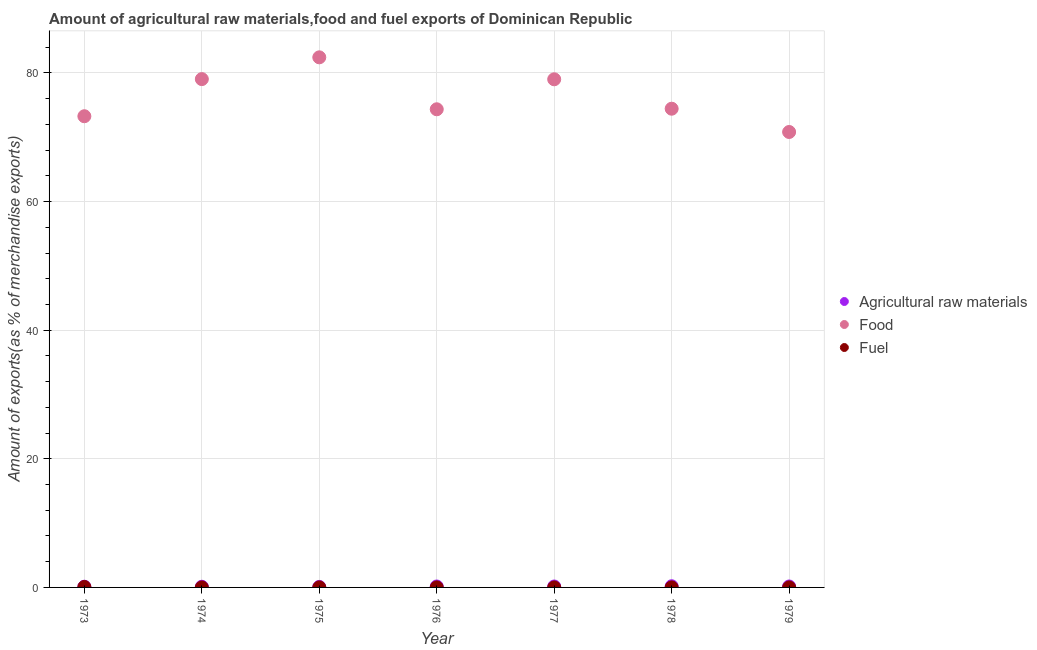What is the percentage of food exports in 1977?
Your answer should be very brief. 79.01. Across all years, what is the maximum percentage of raw materials exports?
Provide a short and direct response. 0.18. Across all years, what is the minimum percentage of fuel exports?
Give a very brief answer. 0. In which year was the percentage of raw materials exports maximum?
Make the answer very short. 1978. What is the total percentage of raw materials exports in the graph?
Offer a terse response. 0.91. What is the difference between the percentage of fuel exports in 1975 and that in 1976?
Your answer should be very brief. 0. What is the difference between the percentage of food exports in 1979 and the percentage of raw materials exports in 1974?
Your response must be concise. 70.71. What is the average percentage of raw materials exports per year?
Offer a very short reply. 0.13. In the year 1979, what is the difference between the percentage of food exports and percentage of raw materials exports?
Your answer should be compact. 70.67. In how many years, is the percentage of fuel exports greater than 24 %?
Your answer should be very brief. 0. What is the ratio of the percentage of fuel exports in 1975 to that in 1976?
Ensure brevity in your answer.  1.2. Is the percentage of food exports in 1978 less than that in 1979?
Provide a succinct answer. No. Is the difference between the percentage of raw materials exports in 1976 and 1978 greater than the difference between the percentage of food exports in 1976 and 1978?
Offer a terse response. Yes. What is the difference between the highest and the second highest percentage of raw materials exports?
Your answer should be very brief. 0.04. What is the difference between the highest and the lowest percentage of fuel exports?
Give a very brief answer. 0.07. In how many years, is the percentage of raw materials exports greater than the average percentage of raw materials exports taken over all years?
Your response must be concise. 4. Does the percentage of food exports monotonically increase over the years?
Give a very brief answer. No. How many dotlines are there?
Ensure brevity in your answer.  3. Are the values on the major ticks of Y-axis written in scientific E-notation?
Offer a terse response. No. Does the graph contain any zero values?
Your answer should be very brief. No. Does the graph contain grids?
Your answer should be very brief. Yes. Where does the legend appear in the graph?
Your answer should be very brief. Center right. How many legend labels are there?
Your answer should be compact. 3. What is the title of the graph?
Your answer should be compact. Amount of agricultural raw materials,food and fuel exports of Dominican Republic. What is the label or title of the Y-axis?
Your response must be concise. Amount of exports(as % of merchandise exports). What is the Amount of exports(as % of merchandise exports) in Agricultural raw materials in 1973?
Make the answer very short. 0.11. What is the Amount of exports(as % of merchandise exports) in Food in 1973?
Your answer should be very brief. 73.27. What is the Amount of exports(as % of merchandise exports) of Fuel in 1973?
Offer a terse response. 0.07. What is the Amount of exports(as % of merchandise exports) of Agricultural raw materials in 1974?
Ensure brevity in your answer.  0.1. What is the Amount of exports(as % of merchandise exports) in Food in 1974?
Keep it short and to the point. 79.04. What is the Amount of exports(as % of merchandise exports) of Fuel in 1974?
Ensure brevity in your answer.  0. What is the Amount of exports(as % of merchandise exports) of Agricultural raw materials in 1975?
Provide a short and direct response. 0.08. What is the Amount of exports(as % of merchandise exports) of Food in 1975?
Offer a very short reply. 82.43. What is the Amount of exports(as % of merchandise exports) of Fuel in 1975?
Make the answer very short. 0. What is the Amount of exports(as % of merchandise exports) of Agricultural raw materials in 1976?
Keep it short and to the point. 0.15. What is the Amount of exports(as % of merchandise exports) of Food in 1976?
Make the answer very short. 74.35. What is the Amount of exports(as % of merchandise exports) in Fuel in 1976?
Give a very brief answer. 0. What is the Amount of exports(as % of merchandise exports) in Agricultural raw materials in 1977?
Give a very brief answer. 0.14. What is the Amount of exports(as % of merchandise exports) in Food in 1977?
Keep it short and to the point. 79.01. What is the Amount of exports(as % of merchandise exports) in Fuel in 1977?
Offer a very short reply. 0. What is the Amount of exports(as % of merchandise exports) in Agricultural raw materials in 1978?
Ensure brevity in your answer.  0.18. What is the Amount of exports(as % of merchandise exports) in Food in 1978?
Your answer should be compact. 74.44. What is the Amount of exports(as % of merchandise exports) of Fuel in 1978?
Offer a very short reply. 0.01. What is the Amount of exports(as % of merchandise exports) of Agricultural raw materials in 1979?
Make the answer very short. 0.15. What is the Amount of exports(as % of merchandise exports) in Food in 1979?
Keep it short and to the point. 70.82. What is the Amount of exports(as % of merchandise exports) in Fuel in 1979?
Your response must be concise. 0. Across all years, what is the maximum Amount of exports(as % of merchandise exports) in Agricultural raw materials?
Provide a short and direct response. 0.18. Across all years, what is the maximum Amount of exports(as % of merchandise exports) in Food?
Keep it short and to the point. 82.43. Across all years, what is the maximum Amount of exports(as % of merchandise exports) in Fuel?
Provide a succinct answer. 0.07. Across all years, what is the minimum Amount of exports(as % of merchandise exports) in Agricultural raw materials?
Give a very brief answer. 0.08. Across all years, what is the minimum Amount of exports(as % of merchandise exports) of Food?
Give a very brief answer. 70.82. Across all years, what is the minimum Amount of exports(as % of merchandise exports) in Fuel?
Your answer should be compact. 0. What is the total Amount of exports(as % of merchandise exports) in Agricultural raw materials in the graph?
Offer a terse response. 0.91. What is the total Amount of exports(as % of merchandise exports) in Food in the graph?
Offer a terse response. 533.36. What is the total Amount of exports(as % of merchandise exports) of Fuel in the graph?
Make the answer very short. 0.09. What is the difference between the Amount of exports(as % of merchandise exports) of Agricultural raw materials in 1973 and that in 1974?
Provide a succinct answer. 0.01. What is the difference between the Amount of exports(as % of merchandise exports) in Food in 1973 and that in 1974?
Offer a terse response. -5.77. What is the difference between the Amount of exports(as % of merchandise exports) in Fuel in 1973 and that in 1974?
Your answer should be compact. 0.07. What is the difference between the Amount of exports(as % of merchandise exports) in Agricultural raw materials in 1973 and that in 1975?
Offer a terse response. 0.03. What is the difference between the Amount of exports(as % of merchandise exports) of Food in 1973 and that in 1975?
Give a very brief answer. -9.16. What is the difference between the Amount of exports(as % of merchandise exports) in Fuel in 1973 and that in 1975?
Give a very brief answer. 0.06. What is the difference between the Amount of exports(as % of merchandise exports) of Agricultural raw materials in 1973 and that in 1976?
Give a very brief answer. -0.03. What is the difference between the Amount of exports(as % of merchandise exports) of Food in 1973 and that in 1976?
Offer a terse response. -1.08. What is the difference between the Amount of exports(as % of merchandise exports) in Fuel in 1973 and that in 1976?
Make the answer very short. 0.07. What is the difference between the Amount of exports(as % of merchandise exports) of Agricultural raw materials in 1973 and that in 1977?
Offer a terse response. -0.03. What is the difference between the Amount of exports(as % of merchandise exports) in Food in 1973 and that in 1977?
Provide a succinct answer. -5.74. What is the difference between the Amount of exports(as % of merchandise exports) in Fuel in 1973 and that in 1977?
Your response must be concise. 0.07. What is the difference between the Amount of exports(as % of merchandise exports) of Agricultural raw materials in 1973 and that in 1978?
Your answer should be compact. -0.07. What is the difference between the Amount of exports(as % of merchandise exports) of Food in 1973 and that in 1978?
Offer a very short reply. -1.17. What is the difference between the Amount of exports(as % of merchandise exports) of Fuel in 1973 and that in 1978?
Offer a very short reply. 0.06. What is the difference between the Amount of exports(as % of merchandise exports) in Agricultural raw materials in 1973 and that in 1979?
Make the answer very short. -0.04. What is the difference between the Amount of exports(as % of merchandise exports) in Food in 1973 and that in 1979?
Provide a succinct answer. 2.45. What is the difference between the Amount of exports(as % of merchandise exports) in Fuel in 1973 and that in 1979?
Offer a terse response. 0.06. What is the difference between the Amount of exports(as % of merchandise exports) of Agricultural raw materials in 1974 and that in 1975?
Provide a succinct answer. 0.02. What is the difference between the Amount of exports(as % of merchandise exports) in Food in 1974 and that in 1975?
Keep it short and to the point. -3.39. What is the difference between the Amount of exports(as % of merchandise exports) of Fuel in 1974 and that in 1975?
Offer a very short reply. -0. What is the difference between the Amount of exports(as % of merchandise exports) in Agricultural raw materials in 1974 and that in 1976?
Keep it short and to the point. -0.04. What is the difference between the Amount of exports(as % of merchandise exports) of Food in 1974 and that in 1976?
Offer a terse response. 4.69. What is the difference between the Amount of exports(as % of merchandise exports) in Fuel in 1974 and that in 1976?
Keep it short and to the point. -0. What is the difference between the Amount of exports(as % of merchandise exports) of Agricultural raw materials in 1974 and that in 1977?
Offer a very short reply. -0.04. What is the difference between the Amount of exports(as % of merchandise exports) of Food in 1974 and that in 1977?
Your response must be concise. 0.03. What is the difference between the Amount of exports(as % of merchandise exports) of Fuel in 1974 and that in 1977?
Provide a succinct answer. 0. What is the difference between the Amount of exports(as % of merchandise exports) of Agricultural raw materials in 1974 and that in 1978?
Ensure brevity in your answer.  -0.08. What is the difference between the Amount of exports(as % of merchandise exports) of Food in 1974 and that in 1978?
Give a very brief answer. 4.6. What is the difference between the Amount of exports(as % of merchandise exports) of Fuel in 1974 and that in 1978?
Offer a very short reply. -0. What is the difference between the Amount of exports(as % of merchandise exports) in Agricultural raw materials in 1974 and that in 1979?
Your answer should be very brief. -0.04. What is the difference between the Amount of exports(as % of merchandise exports) in Food in 1974 and that in 1979?
Offer a very short reply. 8.22. What is the difference between the Amount of exports(as % of merchandise exports) of Fuel in 1974 and that in 1979?
Your answer should be compact. -0. What is the difference between the Amount of exports(as % of merchandise exports) of Agricultural raw materials in 1975 and that in 1976?
Give a very brief answer. -0.07. What is the difference between the Amount of exports(as % of merchandise exports) of Food in 1975 and that in 1976?
Offer a terse response. 8.08. What is the difference between the Amount of exports(as % of merchandise exports) in Fuel in 1975 and that in 1976?
Offer a terse response. 0. What is the difference between the Amount of exports(as % of merchandise exports) of Agricultural raw materials in 1975 and that in 1977?
Offer a terse response. -0.07. What is the difference between the Amount of exports(as % of merchandise exports) of Food in 1975 and that in 1977?
Your answer should be compact. 3.42. What is the difference between the Amount of exports(as % of merchandise exports) in Fuel in 1975 and that in 1977?
Give a very brief answer. 0. What is the difference between the Amount of exports(as % of merchandise exports) of Agricultural raw materials in 1975 and that in 1978?
Offer a terse response. -0.1. What is the difference between the Amount of exports(as % of merchandise exports) of Food in 1975 and that in 1978?
Give a very brief answer. 7.99. What is the difference between the Amount of exports(as % of merchandise exports) of Fuel in 1975 and that in 1978?
Provide a succinct answer. -0. What is the difference between the Amount of exports(as % of merchandise exports) in Agricultural raw materials in 1975 and that in 1979?
Keep it short and to the point. -0.07. What is the difference between the Amount of exports(as % of merchandise exports) in Food in 1975 and that in 1979?
Your response must be concise. 11.61. What is the difference between the Amount of exports(as % of merchandise exports) of Fuel in 1975 and that in 1979?
Your response must be concise. 0. What is the difference between the Amount of exports(as % of merchandise exports) of Agricultural raw materials in 1976 and that in 1977?
Keep it short and to the point. 0. What is the difference between the Amount of exports(as % of merchandise exports) in Food in 1976 and that in 1977?
Give a very brief answer. -4.66. What is the difference between the Amount of exports(as % of merchandise exports) in Fuel in 1976 and that in 1977?
Give a very brief answer. 0. What is the difference between the Amount of exports(as % of merchandise exports) in Agricultural raw materials in 1976 and that in 1978?
Provide a succinct answer. -0.04. What is the difference between the Amount of exports(as % of merchandise exports) of Food in 1976 and that in 1978?
Offer a very short reply. -0.09. What is the difference between the Amount of exports(as % of merchandise exports) of Fuel in 1976 and that in 1978?
Ensure brevity in your answer.  -0. What is the difference between the Amount of exports(as % of merchandise exports) in Agricultural raw materials in 1976 and that in 1979?
Offer a very short reply. -0. What is the difference between the Amount of exports(as % of merchandise exports) of Food in 1976 and that in 1979?
Ensure brevity in your answer.  3.53. What is the difference between the Amount of exports(as % of merchandise exports) of Fuel in 1976 and that in 1979?
Offer a terse response. -0. What is the difference between the Amount of exports(as % of merchandise exports) of Agricultural raw materials in 1977 and that in 1978?
Make the answer very short. -0.04. What is the difference between the Amount of exports(as % of merchandise exports) of Food in 1977 and that in 1978?
Your response must be concise. 4.57. What is the difference between the Amount of exports(as % of merchandise exports) in Fuel in 1977 and that in 1978?
Your answer should be very brief. -0. What is the difference between the Amount of exports(as % of merchandise exports) in Agricultural raw materials in 1977 and that in 1979?
Offer a very short reply. -0. What is the difference between the Amount of exports(as % of merchandise exports) of Food in 1977 and that in 1979?
Give a very brief answer. 8.19. What is the difference between the Amount of exports(as % of merchandise exports) of Fuel in 1977 and that in 1979?
Provide a succinct answer. -0. What is the difference between the Amount of exports(as % of merchandise exports) of Agricultural raw materials in 1978 and that in 1979?
Provide a succinct answer. 0.04. What is the difference between the Amount of exports(as % of merchandise exports) in Food in 1978 and that in 1979?
Keep it short and to the point. 3.62. What is the difference between the Amount of exports(as % of merchandise exports) of Fuel in 1978 and that in 1979?
Offer a terse response. 0. What is the difference between the Amount of exports(as % of merchandise exports) of Agricultural raw materials in 1973 and the Amount of exports(as % of merchandise exports) of Food in 1974?
Keep it short and to the point. -78.93. What is the difference between the Amount of exports(as % of merchandise exports) in Agricultural raw materials in 1973 and the Amount of exports(as % of merchandise exports) in Fuel in 1974?
Offer a very short reply. 0.11. What is the difference between the Amount of exports(as % of merchandise exports) of Food in 1973 and the Amount of exports(as % of merchandise exports) of Fuel in 1974?
Your answer should be very brief. 73.27. What is the difference between the Amount of exports(as % of merchandise exports) of Agricultural raw materials in 1973 and the Amount of exports(as % of merchandise exports) of Food in 1975?
Keep it short and to the point. -82.32. What is the difference between the Amount of exports(as % of merchandise exports) of Agricultural raw materials in 1973 and the Amount of exports(as % of merchandise exports) of Fuel in 1975?
Your answer should be very brief. 0.11. What is the difference between the Amount of exports(as % of merchandise exports) of Food in 1973 and the Amount of exports(as % of merchandise exports) of Fuel in 1975?
Offer a very short reply. 73.26. What is the difference between the Amount of exports(as % of merchandise exports) of Agricultural raw materials in 1973 and the Amount of exports(as % of merchandise exports) of Food in 1976?
Keep it short and to the point. -74.24. What is the difference between the Amount of exports(as % of merchandise exports) in Agricultural raw materials in 1973 and the Amount of exports(as % of merchandise exports) in Fuel in 1976?
Your response must be concise. 0.11. What is the difference between the Amount of exports(as % of merchandise exports) in Food in 1973 and the Amount of exports(as % of merchandise exports) in Fuel in 1976?
Make the answer very short. 73.26. What is the difference between the Amount of exports(as % of merchandise exports) of Agricultural raw materials in 1973 and the Amount of exports(as % of merchandise exports) of Food in 1977?
Give a very brief answer. -78.9. What is the difference between the Amount of exports(as % of merchandise exports) of Agricultural raw materials in 1973 and the Amount of exports(as % of merchandise exports) of Fuel in 1977?
Offer a very short reply. 0.11. What is the difference between the Amount of exports(as % of merchandise exports) in Food in 1973 and the Amount of exports(as % of merchandise exports) in Fuel in 1977?
Your answer should be very brief. 73.27. What is the difference between the Amount of exports(as % of merchandise exports) in Agricultural raw materials in 1973 and the Amount of exports(as % of merchandise exports) in Food in 1978?
Your answer should be very brief. -74.33. What is the difference between the Amount of exports(as % of merchandise exports) in Agricultural raw materials in 1973 and the Amount of exports(as % of merchandise exports) in Fuel in 1978?
Make the answer very short. 0.11. What is the difference between the Amount of exports(as % of merchandise exports) in Food in 1973 and the Amount of exports(as % of merchandise exports) in Fuel in 1978?
Keep it short and to the point. 73.26. What is the difference between the Amount of exports(as % of merchandise exports) in Agricultural raw materials in 1973 and the Amount of exports(as % of merchandise exports) in Food in 1979?
Offer a very short reply. -70.71. What is the difference between the Amount of exports(as % of merchandise exports) in Agricultural raw materials in 1973 and the Amount of exports(as % of merchandise exports) in Fuel in 1979?
Offer a very short reply. 0.11. What is the difference between the Amount of exports(as % of merchandise exports) in Food in 1973 and the Amount of exports(as % of merchandise exports) in Fuel in 1979?
Offer a terse response. 73.26. What is the difference between the Amount of exports(as % of merchandise exports) in Agricultural raw materials in 1974 and the Amount of exports(as % of merchandise exports) in Food in 1975?
Offer a terse response. -82.32. What is the difference between the Amount of exports(as % of merchandise exports) in Agricultural raw materials in 1974 and the Amount of exports(as % of merchandise exports) in Fuel in 1975?
Your answer should be compact. 0.1. What is the difference between the Amount of exports(as % of merchandise exports) of Food in 1974 and the Amount of exports(as % of merchandise exports) of Fuel in 1975?
Offer a terse response. 79.04. What is the difference between the Amount of exports(as % of merchandise exports) of Agricultural raw materials in 1974 and the Amount of exports(as % of merchandise exports) of Food in 1976?
Your answer should be compact. -74.25. What is the difference between the Amount of exports(as % of merchandise exports) of Agricultural raw materials in 1974 and the Amount of exports(as % of merchandise exports) of Fuel in 1976?
Provide a short and direct response. 0.1. What is the difference between the Amount of exports(as % of merchandise exports) in Food in 1974 and the Amount of exports(as % of merchandise exports) in Fuel in 1976?
Keep it short and to the point. 79.04. What is the difference between the Amount of exports(as % of merchandise exports) in Agricultural raw materials in 1974 and the Amount of exports(as % of merchandise exports) in Food in 1977?
Keep it short and to the point. -78.91. What is the difference between the Amount of exports(as % of merchandise exports) in Agricultural raw materials in 1974 and the Amount of exports(as % of merchandise exports) in Fuel in 1977?
Provide a short and direct response. 0.1. What is the difference between the Amount of exports(as % of merchandise exports) of Food in 1974 and the Amount of exports(as % of merchandise exports) of Fuel in 1977?
Keep it short and to the point. 79.04. What is the difference between the Amount of exports(as % of merchandise exports) of Agricultural raw materials in 1974 and the Amount of exports(as % of merchandise exports) of Food in 1978?
Your response must be concise. -74.33. What is the difference between the Amount of exports(as % of merchandise exports) of Agricultural raw materials in 1974 and the Amount of exports(as % of merchandise exports) of Fuel in 1978?
Your answer should be compact. 0.1. What is the difference between the Amount of exports(as % of merchandise exports) of Food in 1974 and the Amount of exports(as % of merchandise exports) of Fuel in 1978?
Your answer should be compact. 79.04. What is the difference between the Amount of exports(as % of merchandise exports) in Agricultural raw materials in 1974 and the Amount of exports(as % of merchandise exports) in Food in 1979?
Your response must be concise. -70.71. What is the difference between the Amount of exports(as % of merchandise exports) of Agricultural raw materials in 1974 and the Amount of exports(as % of merchandise exports) of Fuel in 1979?
Ensure brevity in your answer.  0.1. What is the difference between the Amount of exports(as % of merchandise exports) in Food in 1974 and the Amount of exports(as % of merchandise exports) in Fuel in 1979?
Give a very brief answer. 79.04. What is the difference between the Amount of exports(as % of merchandise exports) of Agricultural raw materials in 1975 and the Amount of exports(as % of merchandise exports) of Food in 1976?
Provide a short and direct response. -74.27. What is the difference between the Amount of exports(as % of merchandise exports) of Agricultural raw materials in 1975 and the Amount of exports(as % of merchandise exports) of Fuel in 1976?
Offer a very short reply. 0.07. What is the difference between the Amount of exports(as % of merchandise exports) of Food in 1975 and the Amount of exports(as % of merchandise exports) of Fuel in 1976?
Make the answer very short. 82.42. What is the difference between the Amount of exports(as % of merchandise exports) of Agricultural raw materials in 1975 and the Amount of exports(as % of merchandise exports) of Food in 1977?
Offer a terse response. -78.93. What is the difference between the Amount of exports(as % of merchandise exports) in Agricultural raw materials in 1975 and the Amount of exports(as % of merchandise exports) in Fuel in 1977?
Your answer should be very brief. 0.08. What is the difference between the Amount of exports(as % of merchandise exports) in Food in 1975 and the Amount of exports(as % of merchandise exports) in Fuel in 1977?
Your answer should be compact. 82.43. What is the difference between the Amount of exports(as % of merchandise exports) in Agricultural raw materials in 1975 and the Amount of exports(as % of merchandise exports) in Food in 1978?
Make the answer very short. -74.36. What is the difference between the Amount of exports(as % of merchandise exports) in Agricultural raw materials in 1975 and the Amount of exports(as % of merchandise exports) in Fuel in 1978?
Make the answer very short. 0.07. What is the difference between the Amount of exports(as % of merchandise exports) of Food in 1975 and the Amount of exports(as % of merchandise exports) of Fuel in 1978?
Keep it short and to the point. 82.42. What is the difference between the Amount of exports(as % of merchandise exports) in Agricultural raw materials in 1975 and the Amount of exports(as % of merchandise exports) in Food in 1979?
Give a very brief answer. -70.74. What is the difference between the Amount of exports(as % of merchandise exports) in Agricultural raw materials in 1975 and the Amount of exports(as % of merchandise exports) in Fuel in 1979?
Your answer should be compact. 0.07. What is the difference between the Amount of exports(as % of merchandise exports) in Food in 1975 and the Amount of exports(as % of merchandise exports) in Fuel in 1979?
Your response must be concise. 82.42. What is the difference between the Amount of exports(as % of merchandise exports) in Agricultural raw materials in 1976 and the Amount of exports(as % of merchandise exports) in Food in 1977?
Your answer should be compact. -78.87. What is the difference between the Amount of exports(as % of merchandise exports) of Agricultural raw materials in 1976 and the Amount of exports(as % of merchandise exports) of Fuel in 1977?
Provide a succinct answer. 0.14. What is the difference between the Amount of exports(as % of merchandise exports) of Food in 1976 and the Amount of exports(as % of merchandise exports) of Fuel in 1977?
Your answer should be very brief. 74.35. What is the difference between the Amount of exports(as % of merchandise exports) in Agricultural raw materials in 1976 and the Amount of exports(as % of merchandise exports) in Food in 1978?
Your answer should be very brief. -74.29. What is the difference between the Amount of exports(as % of merchandise exports) in Agricultural raw materials in 1976 and the Amount of exports(as % of merchandise exports) in Fuel in 1978?
Provide a succinct answer. 0.14. What is the difference between the Amount of exports(as % of merchandise exports) in Food in 1976 and the Amount of exports(as % of merchandise exports) in Fuel in 1978?
Offer a terse response. 74.34. What is the difference between the Amount of exports(as % of merchandise exports) of Agricultural raw materials in 1976 and the Amount of exports(as % of merchandise exports) of Food in 1979?
Provide a short and direct response. -70.67. What is the difference between the Amount of exports(as % of merchandise exports) in Agricultural raw materials in 1976 and the Amount of exports(as % of merchandise exports) in Fuel in 1979?
Provide a short and direct response. 0.14. What is the difference between the Amount of exports(as % of merchandise exports) of Food in 1976 and the Amount of exports(as % of merchandise exports) of Fuel in 1979?
Your answer should be very brief. 74.35. What is the difference between the Amount of exports(as % of merchandise exports) in Agricultural raw materials in 1977 and the Amount of exports(as % of merchandise exports) in Food in 1978?
Your answer should be compact. -74.29. What is the difference between the Amount of exports(as % of merchandise exports) of Agricultural raw materials in 1977 and the Amount of exports(as % of merchandise exports) of Fuel in 1978?
Provide a short and direct response. 0.14. What is the difference between the Amount of exports(as % of merchandise exports) of Food in 1977 and the Amount of exports(as % of merchandise exports) of Fuel in 1978?
Provide a short and direct response. 79.01. What is the difference between the Amount of exports(as % of merchandise exports) of Agricultural raw materials in 1977 and the Amount of exports(as % of merchandise exports) of Food in 1979?
Your response must be concise. -70.67. What is the difference between the Amount of exports(as % of merchandise exports) in Agricultural raw materials in 1977 and the Amount of exports(as % of merchandise exports) in Fuel in 1979?
Your answer should be very brief. 0.14. What is the difference between the Amount of exports(as % of merchandise exports) in Food in 1977 and the Amount of exports(as % of merchandise exports) in Fuel in 1979?
Your response must be concise. 79.01. What is the difference between the Amount of exports(as % of merchandise exports) of Agricultural raw materials in 1978 and the Amount of exports(as % of merchandise exports) of Food in 1979?
Offer a very short reply. -70.63. What is the difference between the Amount of exports(as % of merchandise exports) of Agricultural raw materials in 1978 and the Amount of exports(as % of merchandise exports) of Fuel in 1979?
Make the answer very short. 0.18. What is the difference between the Amount of exports(as % of merchandise exports) in Food in 1978 and the Amount of exports(as % of merchandise exports) in Fuel in 1979?
Provide a succinct answer. 74.43. What is the average Amount of exports(as % of merchandise exports) in Agricultural raw materials per year?
Keep it short and to the point. 0.13. What is the average Amount of exports(as % of merchandise exports) of Food per year?
Your answer should be compact. 76.19. What is the average Amount of exports(as % of merchandise exports) of Fuel per year?
Your answer should be compact. 0.01. In the year 1973, what is the difference between the Amount of exports(as % of merchandise exports) in Agricultural raw materials and Amount of exports(as % of merchandise exports) in Food?
Ensure brevity in your answer.  -73.16. In the year 1973, what is the difference between the Amount of exports(as % of merchandise exports) of Agricultural raw materials and Amount of exports(as % of merchandise exports) of Fuel?
Provide a short and direct response. 0.04. In the year 1973, what is the difference between the Amount of exports(as % of merchandise exports) in Food and Amount of exports(as % of merchandise exports) in Fuel?
Your answer should be very brief. 73.2. In the year 1974, what is the difference between the Amount of exports(as % of merchandise exports) of Agricultural raw materials and Amount of exports(as % of merchandise exports) of Food?
Keep it short and to the point. -78.94. In the year 1974, what is the difference between the Amount of exports(as % of merchandise exports) in Agricultural raw materials and Amount of exports(as % of merchandise exports) in Fuel?
Provide a succinct answer. 0.1. In the year 1974, what is the difference between the Amount of exports(as % of merchandise exports) in Food and Amount of exports(as % of merchandise exports) in Fuel?
Your response must be concise. 79.04. In the year 1975, what is the difference between the Amount of exports(as % of merchandise exports) of Agricultural raw materials and Amount of exports(as % of merchandise exports) of Food?
Make the answer very short. -82.35. In the year 1975, what is the difference between the Amount of exports(as % of merchandise exports) of Agricultural raw materials and Amount of exports(as % of merchandise exports) of Fuel?
Provide a short and direct response. 0.07. In the year 1975, what is the difference between the Amount of exports(as % of merchandise exports) in Food and Amount of exports(as % of merchandise exports) in Fuel?
Your answer should be compact. 82.42. In the year 1976, what is the difference between the Amount of exports(as % of merchandise exports) in Agricultural raw materials and Amount of exports(as % of merchandise exports) in Food?
Give a very brief answer. -74.2. In the year 1976, what is the difference between the Amount of exports(as % of merchandise exports) in Agricultural raw materials and Amount of exports(as % of merchandise exports) in Fuel?
Offer a terse response. 0.14. In the year 1976, what is the difference between the Amount of exports(as % of merchandise exports) of Food and Amount of exports(as % of merchandise exports) of Fuel?
Keep it short and to the point. 74.35. In the year 1977, what is the difference between the Amount of exports(as % of merchandise exports) in Agricultural raw materials and Amount of exports(as % of merchandise exports) in Food?
Offer a terse response. -78.87. In the year 1977, what is the difference between the Amount of exports(as % of merchandise exports) in Agricultural raw materials and Amount of exports(as % of merchandise exports) in Fuel?
Your answer should be very brief. 0.14. In the year 1977, what is the difference between the Amount of exports(as % of merchandise exports) in Food and Amount of exports(as % of merchandise exports) in Fuel?
Give a very brief answer. 79.01. In the year 1978, what is the difference between the Amount of exports(as % of merchandise exports) of Agricultural raw materials and Amount of exports(as % of merchandise exports) of Food?
Offer a very short reply. -74.25. In the year 1978, what is the difference between the Amount of exports(as % of merchandise exports) of Agricultural raw materials and Amount of exports(as % of merchandise exports) of Fuel?
Make the answer very short. 0.18. In the year 1978, what is the difference between the Amount of exports(as % of merchandise exports) in Food and Amount of exports(as % of merchandise exports) in Fuel?
Keep it short and to the point. 74.43. In the year 1979, what is the difference between the Amount of exports(as % of merchandise exports) in Agricultural raw materials and Amount of exports(as % of merchandise exports) in Food?
Offer a very short reply. -70.67. In the year 1979, what is the difference between the Amount of exports(as % of merchandise exports) in Agricultural raw materials and Amount of exports(as % of merchandise exports) in Fuel?
Offer a very short reply. 0.14. In the year 1979, what is the difference between the Amount of exports(as % of merchandise exports) of Food and Amount of exports(as % of merchandise exports) of Fuel?
Your answer should be compact. 70.81. What is the ratio of the Amount of exports(as % of merchandise exports) of Agricultural raw materials in 1973 to that in 1974?
Ensure brevity in your answer.  1.08. What is the ratio of the Amount of exports(as % of merchandise exports) in Food in 1973 to that in 1974?
Make the answer very short. 0.93. What is the ratio of the Amount of exports(as % of merchandise exports) in Fuel in 1973 to that in 1974?
Ensure brevity in your answer.  34.99. What is the ratio of the Amount of exports(as % of merchandise exports) of Agricultural raw materials in 1973 to that in 1975?
Your answer should be very brief. 1.41. What is the ratio of the Amount of exports(as % of merchandise exports) in Fuel in 1973 to that in 1975?
Give a very brief answer. 14.06. What is the ratio of the Amount of exports(as % of merchandise exports) in Agricultural raw materials in 1973 to that in 1976?
Ensure brevity in your answer.  0.76. What is the ratio of the Amount of exports(as % of merchandise exports) of Food in 1973 to that in 1976?
Provide a short and direct response. 0.99. What is the ratio of the Amount of exports(as % of merchandise exports) of Fuel in 1973 to that in 1976?
Your answer should be compact. 16.89. What is the ratio of the Amount of exports(as % of merchandise exports) in Agricultural raw materials in 1973 to that in 1977?
Give a very brief answer. 0.77. What is the ratio of the Amount of exports(as % of merchandise exports) of Food in 1973 to that in 1977?
Offer a very short reply. 0.93. What is the ratio of the Amount of exports(as % of merchandise exports) in Fuel in 1973 to that in 1977?
Ensure brevity in your answer.  50.92. What is the ratio of the Amount of exports(as % of merchandise exports) of Agricultural raw materials in 1973 to that in 1978?
Keep it short and to the point. 0.61. What is the ratio of the Amount of exports(as % of merchandise exports) of Food in 1973 to that in 1978?
Provide a succinct answer. 0.98. What is the ratio of the Amount of exports(as % of merchandise exports) in Fuel in 1973 to that in 1978?
Provide a short and direct response. 13.29. What is the ratio of the Amount of exports(as % of merchandise exports) in Agricultural raw materials in 1973 to that in 1979?
Keep it short and to the point. 0.76. What is the ratio of the Amount of exports(as % of merchandise exports) in Food in 1973 to that in 1979?
Provide a succinct answer. 1.03. What is the ratio of the Amount of exports(as % of merchandise exports) of Fuel in 1973 to that in 1979?
Keep it short and to the point. 15.9. What is the ratio of the Amount of exports(as % of merchandise exports) in Agricultural raw materials in 1974 to that in 1975?
Your answer should be very brief. 1.31. What is the ratio of the Amount of exports(as % of merchandise exports) in Food in 1974 to that in 1975?
Give a very brief answer. 0.96. What is the ratio of the Amount of exports(as % of merchandise exports) of Fuel in 1974 to that in 1975?
Offer a terse response. 0.4. What is the ratio of the Amount of exports(as % of merchandise exports) of Agricultural raw materials in 1974 to that in 1976?
Provide a short and direct response. 0.71. What is the ratio of the Amount of exports(as % of merchandise exports) of Food in 1974 to that in 1976?
Provide a short and direct response. 1.06. What is the ratio of the Amount of exports(as % of merchandise exports) in Fuel in 1974 to that in 1976?
Offer a very short reply. 0.48. What is the ratio of the Amount of exports(as % of merchandise exports) in Agricultural raw materials in 1974 to that in 1977?
Offer a terse response. 0.71. What is the ratio of the Amount of exports(as % of merchandise exports) of Food in 1974 to that in 1977?
Offer a terse response. 1. What is the ratio of the Amount of exports(as % of merchandise exports) in Fuel in 1974 to that in 1977?
Give a very brief answer. 1.46. What is the ratio of the Amount of exports(as % of merchandise exports) of Agricultural raw materials in 1974 to that in 1978?
Your answer should be very brief. 0.56. What is the ratio of the Amount of exports(as % of merchandise exports) of Food in 1974 to that in 1978?
Your answer should be very brief. 1.06. What is the ratio of the Amount of exports(as % of merchandise exports) of Fuel in 1974 to that in 1978?
Offer a terse response. 0.38. What is the ratio of the Amount of exports(as % of merchandise exports) in Agricultural raw materials in 1974 to that in 1979?
Offer a very short reply. 0.7. What is the ratio of the Amount of exports(as % of merchandise exports) of Food in 1974 to that in 1979?
Your answer should be compact. 1.12. What is the ratio of the Amount of exports(as % of merchandise exports) of Fuel in 1974 to that in 1979?
Make the answer very short. 0.45. What is the ratio of the Amount of exports(as % of merchandise exports) of Agricultural raw materials in 1975 to that in 1976?
Your answer should be very brief. 0.54. What is the ratio of the Amount of exports(as % of merchandise exports) of Food in 1975 to that in 1976?
Your answer should be very brief. 1.11. What is the ratio of the Amount of exports(as % of merchandise exports) in Fuel in 1975 to that in 1976?
Your answer should be compact. 1.2. What is the ratio of the Amount of exports(as % of merchandise exports) of Agricultural raw materials in 1975 to that in 1977?
Your answer should be compact. 0.55. What is the ratio of the Amount of exports(as % of merchandise exports) of Food in 1975 to that in 1977?
Offer a very short reply. 1.04. What is the ratio of the Amount of exports(as % of merchandise exports) of Fuel in 1975 to that in 1977?
Offer a very short reply. 3.62. What is the ratio of the Amount of exports(as % of merchandise exports) in Agricultural raw materials in 1975 to that in 1978?
Ensure brevity in your answer.  0.43. What is the ratio of the Amount of exports(as % of merchandise exports) in Food in 1975 to that in 1978?
Give a very brief answer. 1.11. What is the ratio of the Amount of exports(as % of merchandise exports) in Fuel in 1975 to that in 1978?
Your answer should be very brief. 0.94. What is the ratio of the Amount of exports(as % of merchandise exports) in Agricultural raw materials in 1975 to that in 1979?
Provide a short and direct response. 0.54. What is the ratio of the Amount of exports(as % of merchandise exports) of Food in 1975 to that in 1979?
Make the answer very short. 1.16. What is the ratio of the Amount of exports(as % of merchandise exports) of Fuel in 1975 to that in 1979?
Keep it short and to the point. 1.13. What is the ratio of the Amount of exports(as % of merchandise exports) in Agricultural raw materials in 1976 to that in 1977?
Ensure brevity in your answer.  1.01. What is the ratio of the Amount of exports(as % of merchandise exports) of Food in 1976 to that in 1977?
Provide a short and direct response. 0.94. What is the ratio of the Amount of exports(as % of merchandise exports) in Fuel in 1976 to that in 1977?
Your answer should be compact. 3.01. What is the ratio of the Amount of exports(as % of merchandise exports) in Agricultural raw materials in 1976 to that in 1978?
Your answer should be very brief. 0.79. What is the ratio of the Amount of exports(as % of merchandise exports) in Food in 1976 to that in 1978?
Your answer should be very brief. 1. What is the ratio of the Amount of exports(as % of merchandise exports) of Fuel in 1976 to that in 1978?
Offer a terse response. 0.79. What is the ratio of the Amount of exports(as % of merchandise exports) of Food in 1976 to that in 1979?
Make the answer very short. 1.05. What is the ratio of the Amount of exports(as % of merchandise exports) of Agricultural raw materials in 1977 to that in 1978?
Your answer should be compact. 0.79. What is the ratio of the Amount of exports(as % of merchandise exports) of Food in 1977 to that in 1978?
Ensure brevity in your answer.  1.06. What is the ratio of the Amount of exports(as % of merchandise exports) in Fuel in 1977 to that in 1978?
Offer a terse response. 0.26. What is the ratio of the Amount of exports(as % of merchandise exports) of Agricultural raw materials in 1977 to that in 1979?
Offer a very short reply. 0.98. What is the ratio of the Amount of exports(as % of merchandise exports) in Food in 1977 to that in 1979?
Your answer should be compact. 1.12. What is the ratio of the Amount of exports(as % of merchandise exports) in Fuel in 1977 to that in 1979?
Your response must be concise. 0.31. What is the ratio of the Amount of exports(as % of merchandise exports) in Agricultural raw materials in 1978 to that in 1979?
Offer a very short reply. 1.25. What is the ratio of the Amount of exports(as % of merchandise exports) in Food in 1978 to that in 1979?
Offer a very short reply. 1.05. What is the ratio of the Amount of exports(as % of merchandise exports) in Fuel in 1978 to that in 1979?
Ensure brevity in your answer.  1.2. What is the difference between the highest and the second highest Amount of exports(as % of merchandise exports) in Agricultural raw materials?
Offer a very short reply. 0.04. What is the difference between the highest and the second highest Amount of exports(as % of merchandise exports) of Food?
Offer a very short reply. 3.39. What is the difference between the highest and the second highest Amount of exports(as % of merchandise exports) of Fuel?
Your answer should be very brief. 0.06. What is the difference between the highest and the lowest Amount of exports(as % of merchandise exports) of Agricultural raw materials?
Keep it short and to the point. 0.1. What is the difference between the highest and the lowest Amount of exports(as % of merchandise exports) of Food?
Provide a short and direct response. 11.61. What is the difference between the highest and the lowest Amount of exports(as % of merchandise exports) in Fuel?
Ensure brevity in your answer.  0.07. 